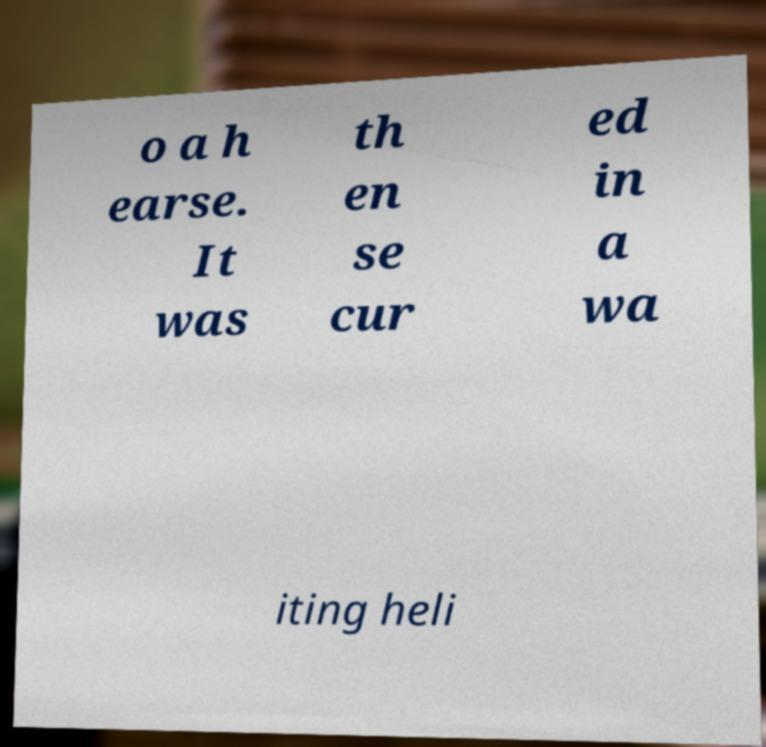Can you read and provide the text displayed in the image?This photo seems to have some interesting text. Can you extract and type it out for me? o a h earse. It was th en se cur ed in a wa iting heli 